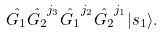<formula> <loc_0><loc_0><loc_500><loc_500>\hat { G _ { 1 } } \hat { G _ { 2 } } ^ { j _ { 3 } } \hat { G _ { 1 } } ^ { j _ { 2 } } \hat { G _ { 2 } } ^ { j _ { 1 } } | s _ { 1 } \rangle .</formula> 